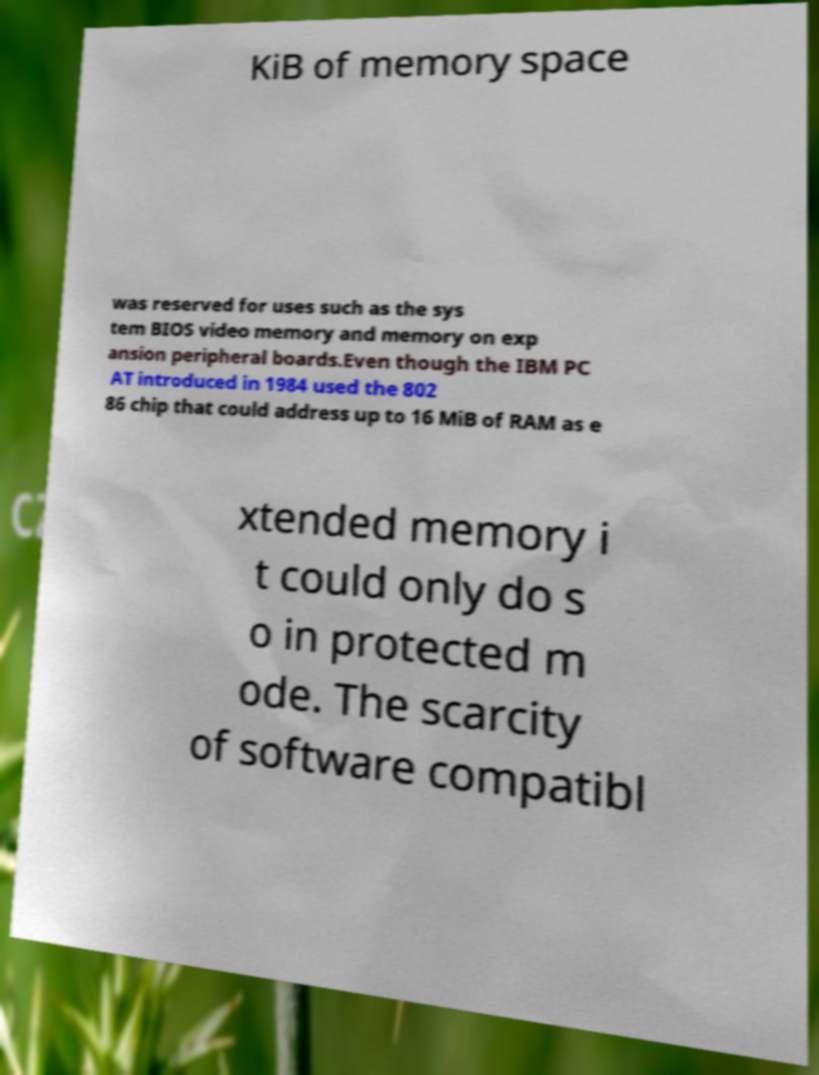Can you read and provide the text displayed in the image?This photo seems to have some interesting text. Can you extract and type it out for me? KiB of memory space was reserved for uses such as the sys tem BIOS video memory and memory on exp ansion peripheral boards.Even though the IBM PC AT introduced in 1984 used the 802 86 chip that could address up to 16 MiB of RAM as e xtended memory i t could only do s o in protected m ode. The scarcity of software compatibl 